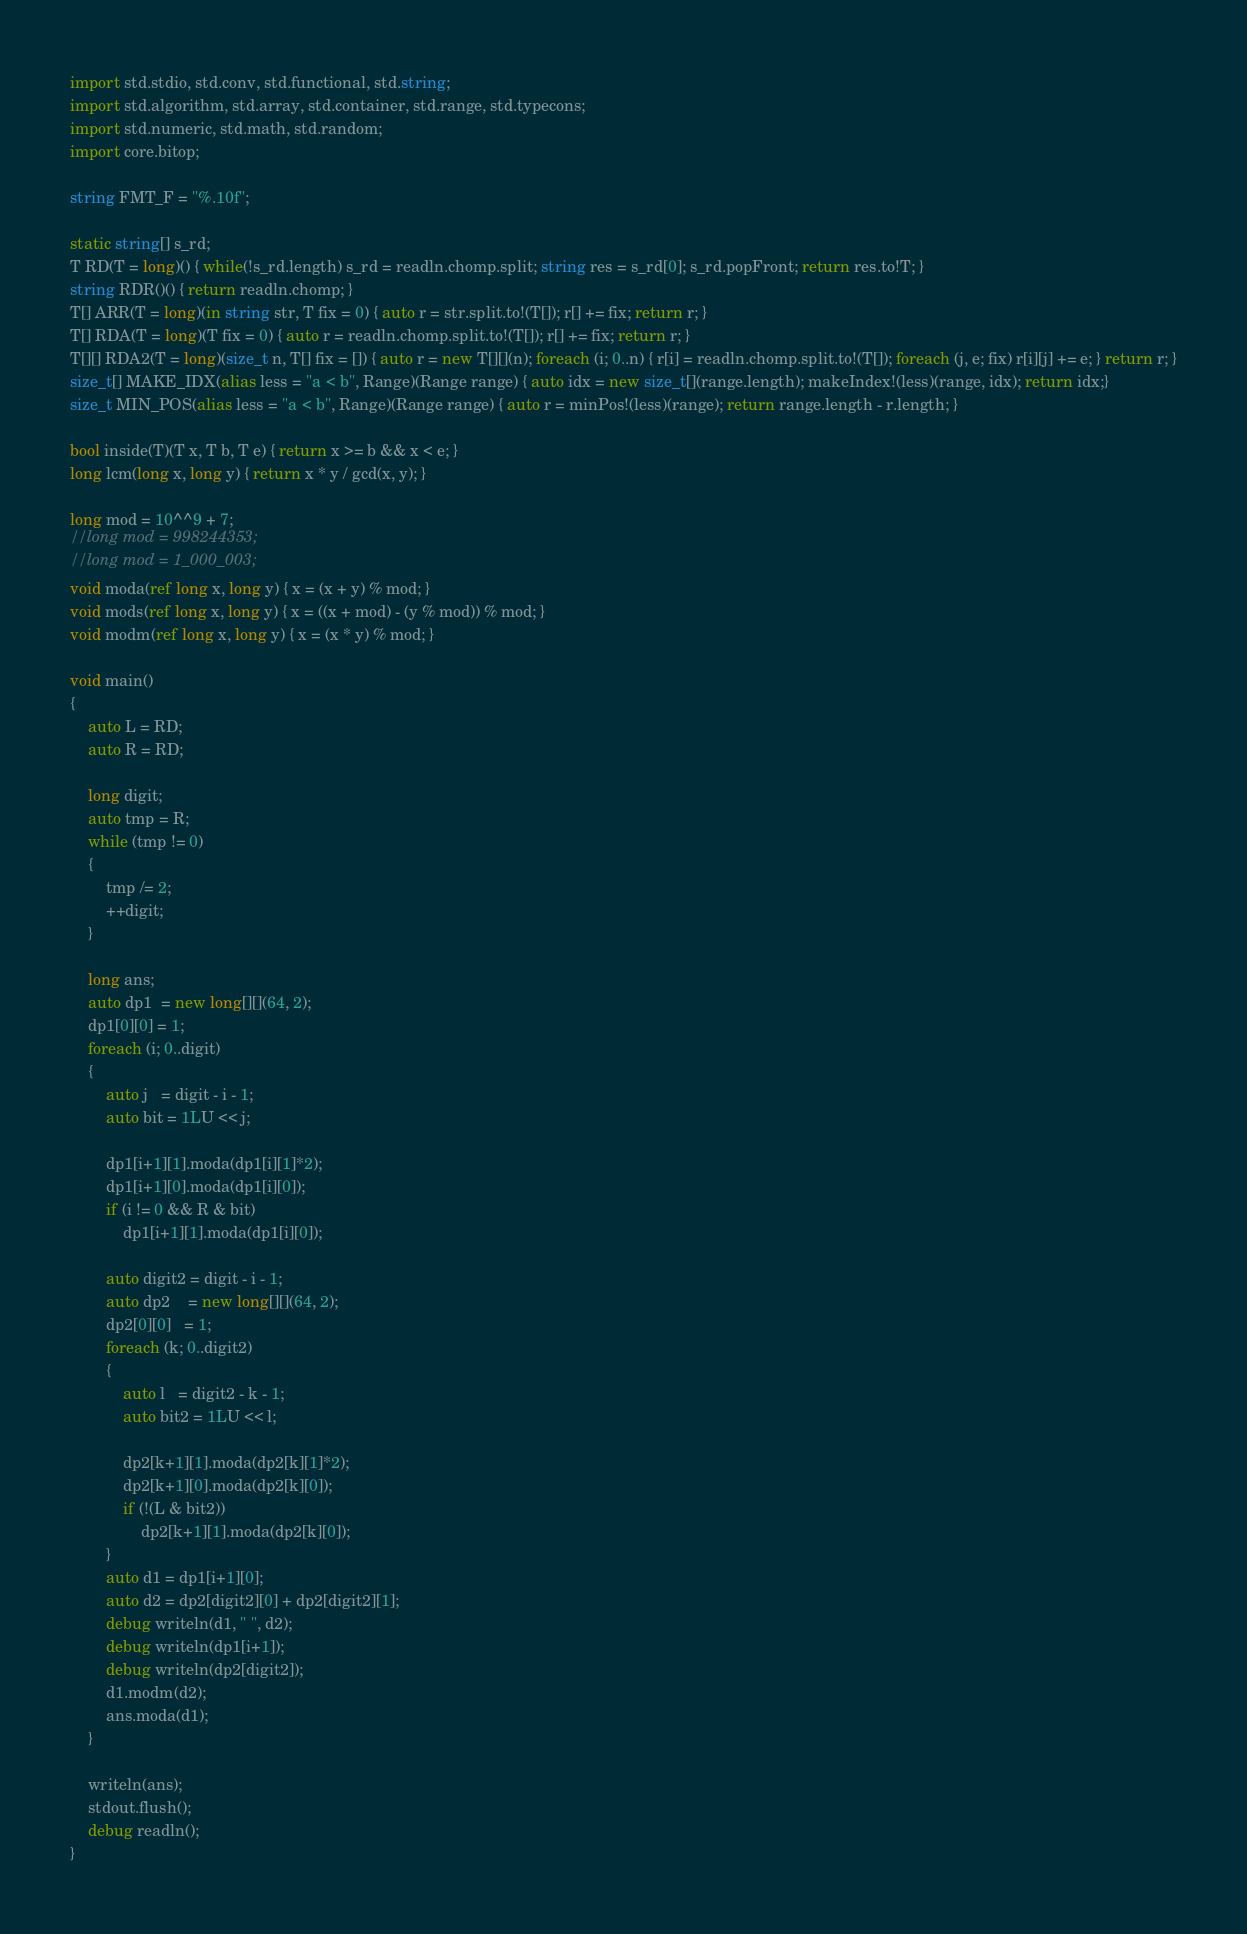<code> <loc_0><loc_0><loc_500><loc_500><_D_>import std.stdio, std.conv, std.functional, std.string;
import std.algorithm, std.array, std.container, std.range, std.typecons;
import std.numeric, std.math, std.random;
import core.bitop;

string FMT_F = "%.10f";

static string[] s_rd;
T RD(T = long)() { while(!s_rd.length) s_rd = readln.chomp.split; string res = s_rd[0]; s_rd.popFront; return res.to!T; }
string RDR()() { return readln.chomp; }
T[] ARR(T = long)(in string str, T fix = 0) { auto r = str.split.to!(T[]); r[] += fix; return r; }
T[] RDA(T = long)(T fix = 0) { auto r = readln.chomp.split.to!(T[]); r[] += fix; return r; }
T[][] RDA2(T = long)(size_t n, T[] fix = []) { auto r = new T[][](n); foreach (i; 0..n) { r[i] = readln.chomp.split.to!(T[]); foreach (j, e; fix) r[i][j] += e; } return r; }
size_t[] MAKE_IDX(alias less = "a < b", Range)(Range range) { auto idx = new size_t[](range.length); makeIndex!(less)(range, idx); return idx;}
size_t MIN_POS(alias less = "a < b", Range)(Range range) { auto r = minPos!(less)(range); return range.length - r.length; }

bool inside(T)(T x, T b, T e) { return x >= b && x < e; }
long lcm(long x, long y) { return x * y / gcd(x, y); }

long mod = 10^^9 + 7;
//long mod = 998244353;
//long mod = 1_000_003;
void moda(ref long x, long y) { x = (x + y) % mod; }
void mods(ref long x, long y) { x = ((x + mod) - (y % mod)) % mod; }
void modm(ref long x, long y) { x = (x * y) % mod; }

void main()
{
	auto L = RD;
	auto R = RD;

	long digit;
	auto tmp = R;
	while (tmp != 0)
	{
		tmp /= 2;
		++digit;
	}

	long ans;
	auto dp1  = new long[][](64, 2);
	dp1[0][0] = 1;
	foreach (i; 0..digit)
	{
		auto j   = digit - i - 1;
		auto bit = 1LU << j;

		dp1[i+1][1].moda(dp1[i][1]*2);
		dp1[i+1][0].moda(dp1[i][0]);
		if (i != 0 && R & bit)
			dp1[i+1][1].moda(dp1[i][0]);

		auto digit2 = digit - i - 1;
		auto dp2    = new long[][](64, 2);
		dp2[0][0]   = 1;
		foreach (k; 0..digit2)
		{
			auto l   = digit2 - k - 1;
			auto bit2 = 1LU << l;

			dp2[k+1][1].moda(dp2[k][1]*2);
			dp2[k+1][0].moda(dp2[k][0]);
			if (!(L & bit2))
				dp2[k+1][1].moda(dp2[k][0]);
		}
		auto d1 = dp1[i+1][0];
		auto d2 = dp2[digit2][0] + dp2[digit2][1];
		debug writeln(d1, " ", d2);
		debug writeln(dp1[i+1]);
		debug writeln(dp2[digit2]);
		d1.modm(d2);
		ans.moda(d1);
	}

	writeln(ans);
	stdout.flush();
	debug readln();
}</code> 